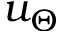<formula> <loc_0><loc_0><loc_500><loc_500>u _ { \Theta }</formula> 